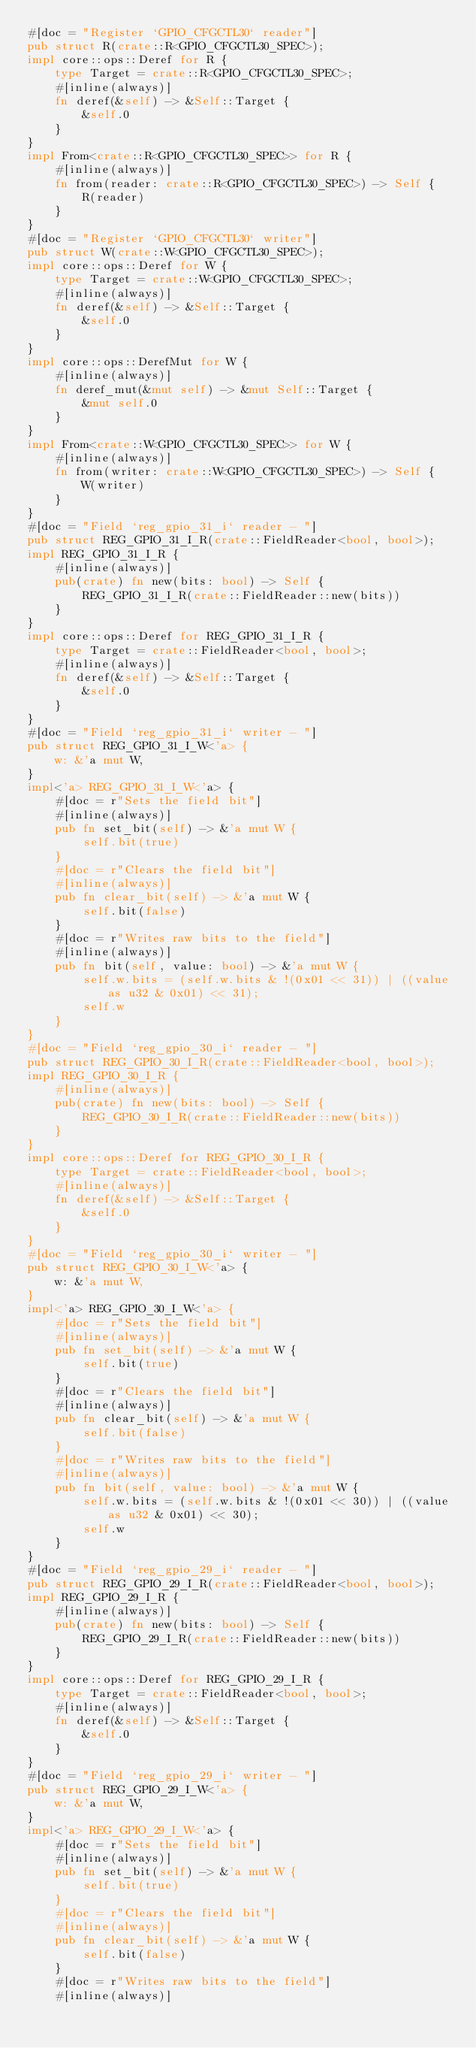<code> <loc_0><loc_0><loc_500><loc_500><_Rust_>#[doc = "Register `GPIO_CFGCTL30` reader"]
pub struct R(crate::R<GPIO_CFGCTL30_SPEC>);
impl core::ops::Deref for R {
    type Target = crate::R<GPIO_CFGCTL30_SPEC>;
    #[inline(always)]
    fn deref(&self) -> &Self::Target {
        &self.0
    }
}
impl From<crate::R<GPIO_CFGCTL30_SPEC>> for R {
    #[inline(always)]
    fn from(reader: crate::R<GPIO_CFGCTL30_SPEC>) -> Self {
        R(reader)
    }
}
#[doc = "Register `GPIO_CFGCTL30` writer"]
pub struct W(crate::W<GPIO_CFGCTL30_SPEC>);
impl core::ops::Deref for W {
    type Target = crate::W<GPIO_CFGCTL30_SPEC>;
    #[inline(always)]
    fn deref(&self) -> &Self::Target {
        &self.0
    }
}
impl core::ops::DerefMut for W {
    #[inline(always)]
    fn deref_mut(&mut self) -> &mut Self::Target {
        &mut self.0
    }
}
impl From<crate::W<GPIO_CFGCTL30_SPEC>> for W {
    #[inline(always)]
    fn from(writer: crate::W<GPIO_CFGCTL30_SPEC>) -> Self {
        W(writer)
    }
}
#[doc = "Field `reg_gpio_31_i` reader - "]
pub struct REG_GPIO_31_I_R(crate::FieldReader<bool, bool>);
impl REG_GPIO_31_I_R {
    #[inline(always)]
    pub(crate) fn new(bits: bool) -> Self {
        REG_GPIO_31_I_R(crate::FieldReader::new(bits))
    }
}
impl core::ops::Deref for REG_GPIO_31_I_R {
    type Target = crate::FieldReader<bool, bool>;
    #[inline(always)]
    fn deref(&self) -> &Self::Target {
        &self.0
    }
}
#[doc = "Field `reg_gpio_31_i` writer - "]
pub struct REG_GPIO_31_I_W<'a> {
    w: &'a mut W,
}
impl<'a> REG_GPIO_31_I_W<'a> {
    #[doc = r"Sets the field bit"]
    #[inline(always)]
    pub fn set_bit(self) -> &'a mut W {
        self.bit(true)
    }
    #[doc = r"Clears the field bit"]
    #[inline(always)]
    pub fn clear_bit(self) -> &'a mut W {
        self.bit(false)
    }
    #[doc = r"Writes raw bits to the field"]
    #[inline(always)]
    pub fn bit(self, value: bool) -> &'a mut W {
        self.w.bits = (self.w.bits & !(0x01 << 31)) | ((value as u32 & 0x01) << 31);
        self.w
    }
}
#[doc = "Field `reg_gpio_30_i` reader - "]
pub struct REG_GPIO_30_I_R(crate::FieldReader<bool, bool>);
impl REG_GPIO_30_I_R {
    #[inline(always)]
    pub(crate) fn new(bits: bool) -> Self {
        REG_GPIO_30_I_R(crate::FieldReader::new(bits))
    }
}
impl core::ops::Deref for REG_GPIO_30_I_R {
    type Target = crate::FieldReader<bool, bool>;
    #[inline(always)]
    fn deref(&self) -> &Self::Target {
        &self.0
    }
}
#[doc = "Field `reg_gpio_30_i` writer - "]
pub struct REG_GPIO_30_I_W<'a> {
    w: &'a mut W,
}
impl<'a> REG_GPIO_30_I_W<'a> {
    #[doc = r"Sets the field bit"]
    #[inline(always)]
    pub fn set_bit(self) -> &'a mut W {
        self.bit(true)
    }
    #[doc = r"Clears the field bit"]
    #[inline(always)]
    pub fn clear_bit(self) -> &'a mut W {
        self.bit(false)
    }
    #[doc = r"Writes raw bits to the field"]
    #[inline(always)]
    pub fn bit(self, value: bool) -> &'a mut W {
        self.w.bits = (self.w.bits & !(0x01 << 30)) | ((value as u32 & 0x01) << 30);
        self.w
    }
}
#[doc = "Field `reg_gpio_29_i` reader - "]
pub struct REG_GPIO_29_I_R(crate::FieldReader<bool, bool>);
impl REG_GPIO_29_I_R {
    #[inline(always)]
    pub(crate) fn new(bits: bool) -> Self {
        REG_GPIO_29_I_R(crate::FieldReader::new(bits))
    }
}
impl core::ops::Deref for REG_GPIO_29_I_R {
    type Target = crate::FieldReader<bool, bool>;
    #[inline(always)]
    fn deref(&self) -> &Self::Target {
        &self.0
    }
}
#[doc = "Field `reg_gpio_29_i` writer - "]
pub struct REG_GPIO_29_I_W<'a> {
    w: &'a mut W,
}
impl<'a> REG_GPIO_29_I_W<'a> {
    #[doc = r"Sets the field bit"]
    #[inline(always)]
    pub fn set_bit(self) -> &'a mut W {
        self.bit(true)
    }
    #[doc = r"Clears the field bit"]
    #[inline(always)]
    pub fn clear_bit(self) -> &'a mut W {
        self.bit(false)
    }
    #[doc = r"Writes raw bits to the field"]
    #[inline(always)]</code> 